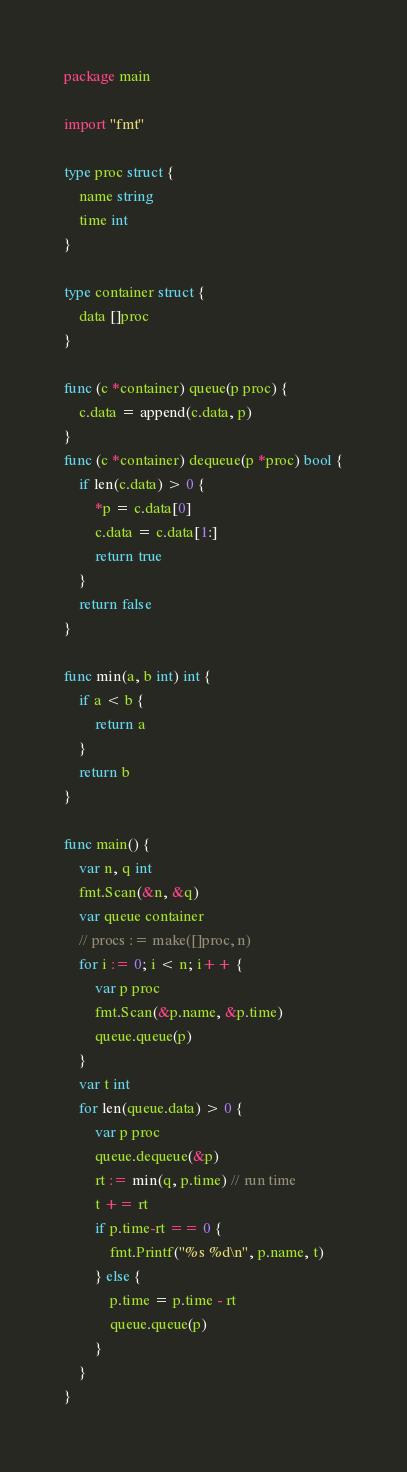<code> <loc_0><loc_0><loc_500><loc_500><_Go_>package main

import "fmt"

type proc struct {
	name string
	time int
}

type container struct {
	data []proc
}

func (c *container) queue(p proc) {
	c.data = append(c.data, p)
}
func (c *container) dequeue(p *proc) bool {
	if len(c.data) > 0 {
		*p = c.data[0]
		c.data = c.data[1:]
		return true
	}
	return false
}

func min(a, b int) int {
	if a < b {
		return a
	}
	return b
}

func main() {
	var n, q int
	fmt.Scan(&n, &q)
	var queue container
	// procs := make([]proc, n)
	for i := 0; i < n; i++ {
		var p proc
		fmt.Scan(&p.name, &p.time)
		queue.queue(p)
	}
	var t int
	for len(queue.data) > 0 {
		var p proc
		queue.dequeue(&p)
		rt := min(q, p.time) // run time
		t += rt
		if p.time-rt == 0 {
			fmt.Printf("%s %d\n", p.name, t)
		} else {
			p.time = p.time - rt
			queue.queue(p)
		}
	}
}

</code> 